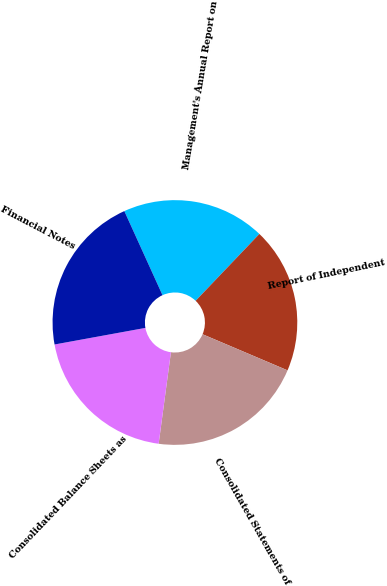Convert chart to OTSL. <chart><loc_0><loc_0><loc_500><loc_500><pie_chart><fcel>Management's Annual Report on<fcel>Report of Independent<fcel>Consolidated Statements of<fcel>Consolidated Balance Sheets as<fcel>Financial Notes<nl><fcel>18.91%<fcel>19.27%<fcel>20.73%<fcel>20.0%<fcel>21.09%<nl></chart> 